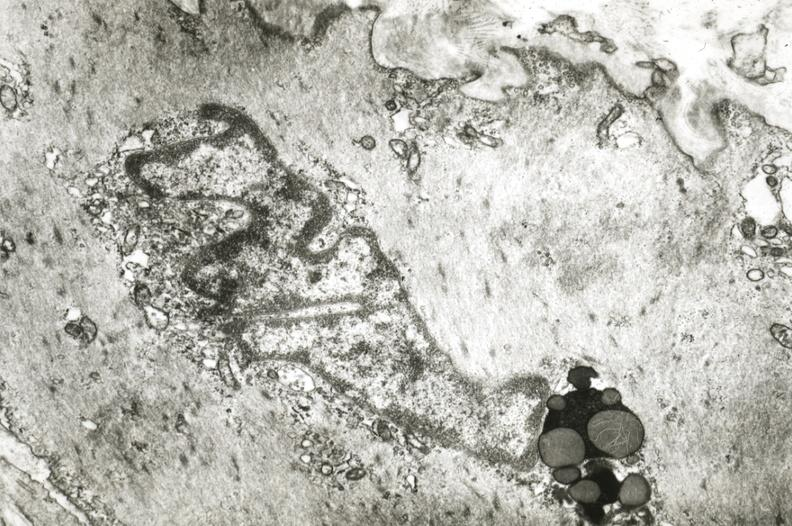what does this image show?
Answer the question using a single word or phrase. Intimal smooth muscle cell with lipochrome pigment 